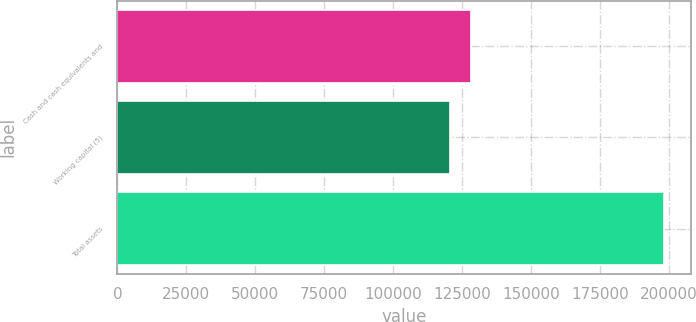<chart> <loc_0><loc_0><loc_500><loc_500><bar_chart><fcel>Cash and cash equivalents and<fcel>Working capital (5)<fcel>Total assets<nl><fcel>128427<fcel>120656<fcel>198366<nl></chart> 